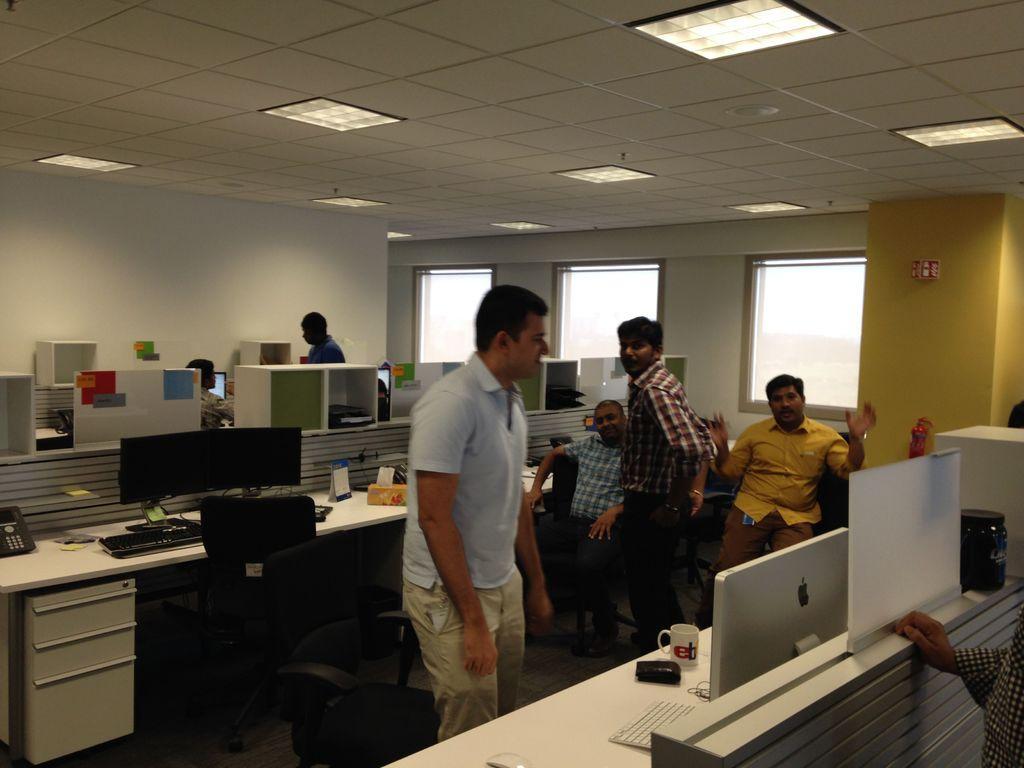Could you give a brief overview of what you see in this image? There are two persons standing on the either side of the table which has desktops on it and there are two people sitting in the background. 